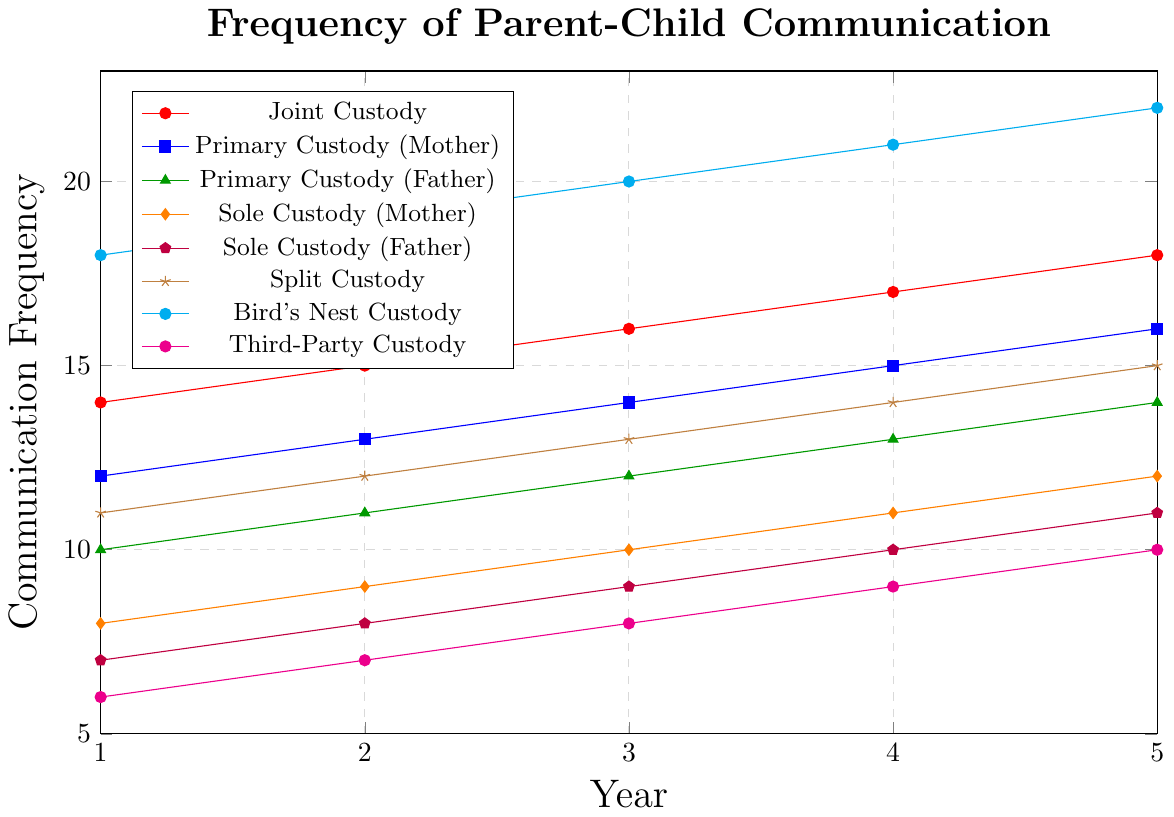What is the frequency of parent-child communication for Bird's Nest Custody in Year 3? The Bird's Nest Custody line (cyan) shows that in Year 3, the frequency of communication is 20.
Answer: 20 Which custody arrangement had the lowest communication frequency in Year 1? Looking at Year 1 across all the lines, Third-Party Custody (magenta) has the lowest frequency, which is 6.
Answer: Third-Party Custody How did the frequency of communication change for Joint Custody from Year 2 to Year 4? Joint Custody (red) went from 15 in Year 2 to 17 in Year 4. The change is 17 - 15 = 2.
Answer: Increased by 2 Which custody arrangement showed the greatest increase in communication frequency over the 5-year period? Bird's Nest Custody (cyan) started at 18 and ended at 22. The increase is 22 - 18 = 4, which is the greatest among all.
Answer: Bird's Nest Custody Compare the communication frequencies between Primary Custody (Mother) and Sole Custody (Father) in Year 5. In Year 5, Primary Custody (Mother) (blue) is at 16 and Sole Custody (Father) (purple) is at 11. 16 - 11 = 5
Answer: Primary Custody (Mother) is 5 units higher Which custody arrangement had a consistent yearly increase in communication frequency? All custody arrangements have increased each year, but Bird's Nest Custody (cyan) line shows a consistent, steady rise each year from 18 to 22.
Answer: All arrangements, notably Bird's Nest Custody What is the average communication frequency for Primary Custody (Father) over the 5 years? The values for Primary Custody (Father) (green) are 10, 11, 12, 13, and 14. The sum is 10 + 11 + 12 + 13 + 14 = 60, and the average is 60/5 = 12.
Answer: 12 Which custody arrangements have equal frequencies in Year 4? In Year 4, both Sole Custody (Mother) (10) and Third-Party Custody (9) are unique, so no arrangements are equal in this year.
Answer: None What is the median frequency value for Split Custody over the 5 years? Split Custody (brown) values are 11, 12, 13, 14, and 15. The median value in this sorted list is the middle value, which is 13.
Answer: 13 